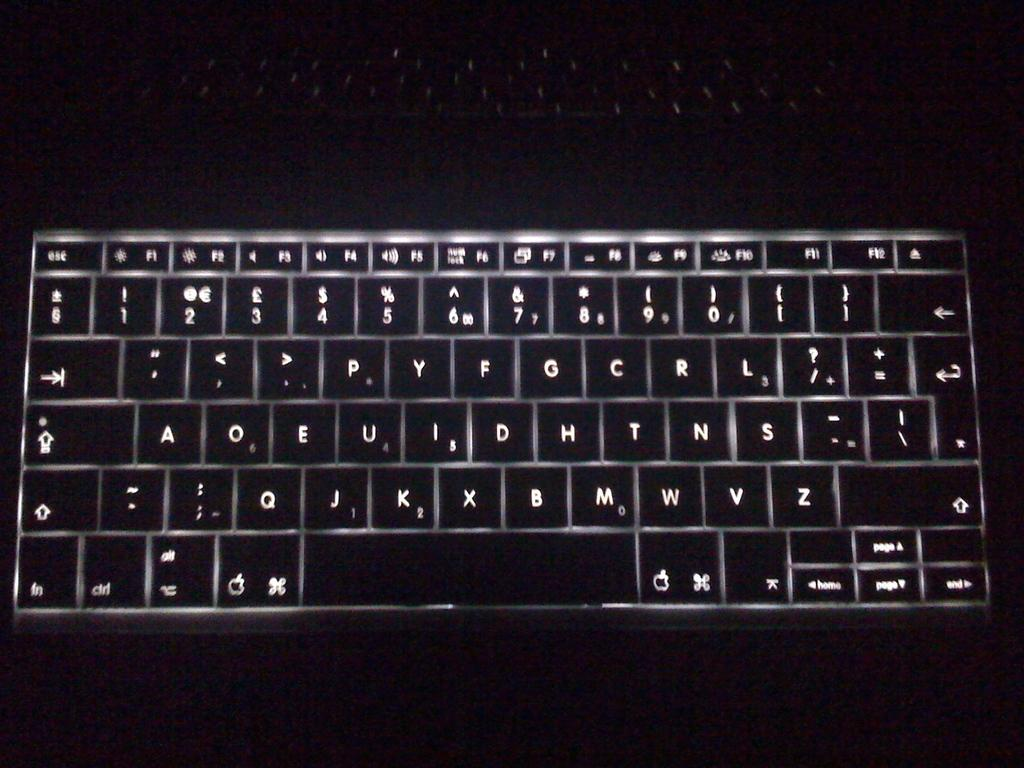<image>
Create a compact narrative representing the image presented. The keyboard lit up has the W key next to the M 